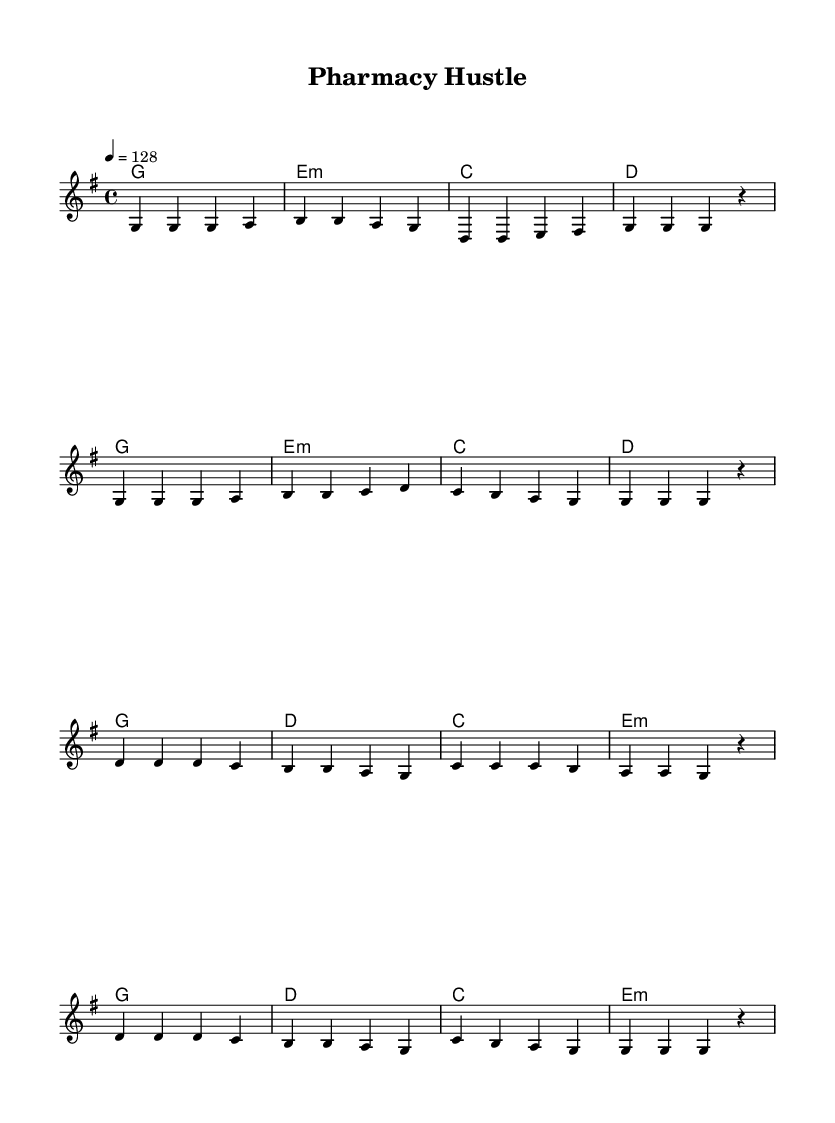What is the key signature of this music? The key signature is G major, which has one sharp (F#).
Answer: G major What is the time signature of this music? The time signature is 4/4, indicating there are four beats in each measure.
Answer: 4/4 What is the tempo marking for this piece? The tempo marking is set at 128 beats per minute.
Answer: 128 How many measures are in the chorus section? The chorus consists of four measures as indicated by the grouping of notes.
Answer: 4 What are the first two words of the verse? The first two words of the verse are "Stock" and "ing," found at the start of the lyrics.
Answer: Stock ing Why is this piece categorized as upbeat pop? This piece is categorized as upbeat pop due to its lively tempo, positive lyrics, and repetitive structure that encourages engagement. The tempo of 128 and the positive message about teamwork further support this classification.
Answer: Upbeat pop 